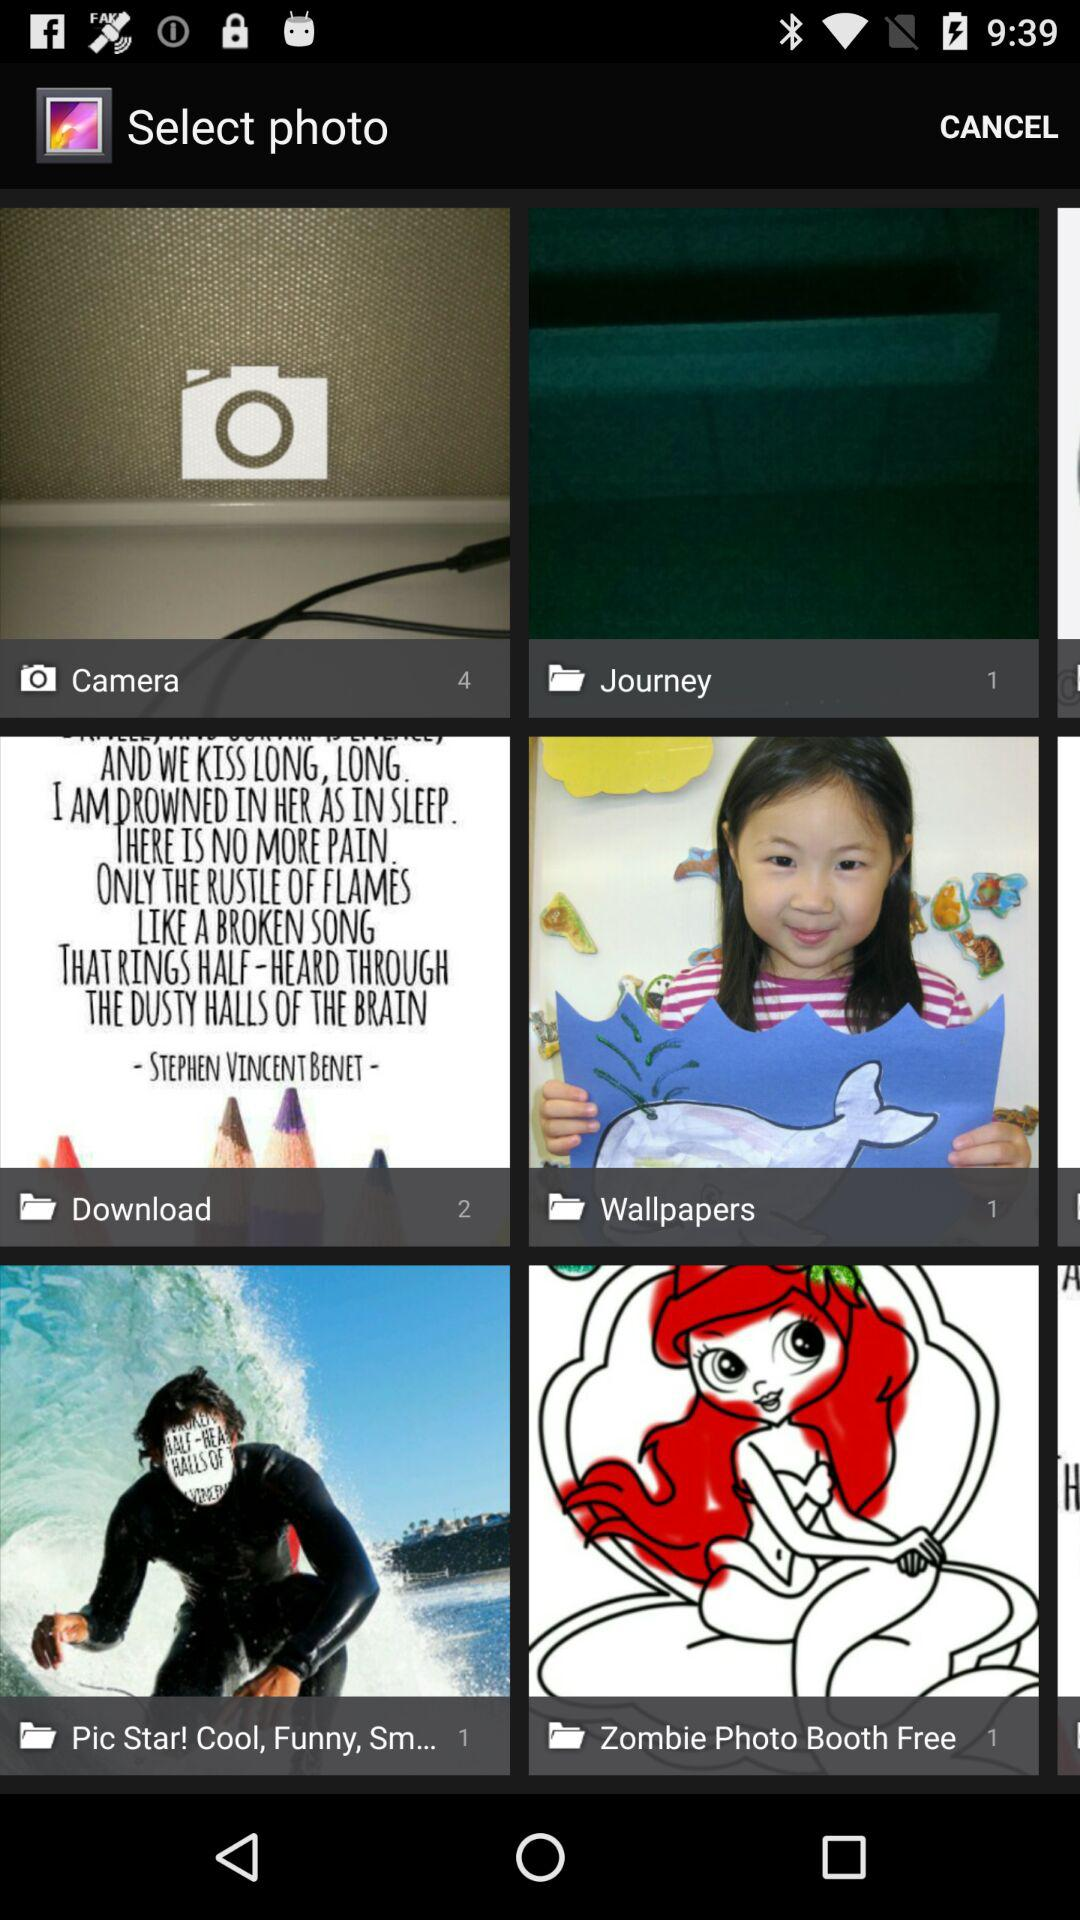What is the total number of images in the "Download" folder? The total number of images in the "Download" folder is 2. 